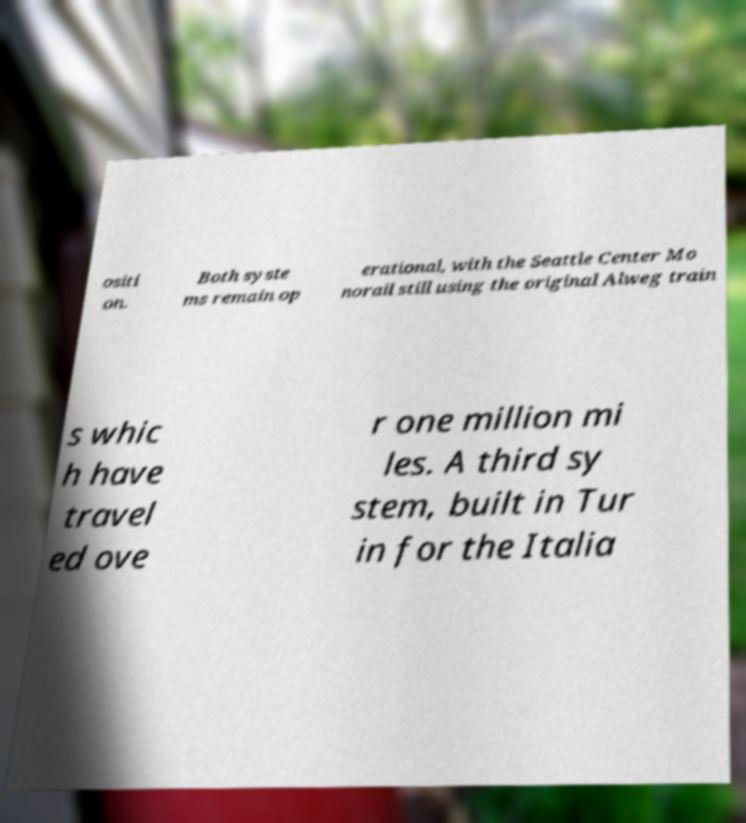Can you accurately transcribe the text from the provided image for me? ositi on. Both syste ms remain op erational, with the Seattle Center Mo norail still using the original Alweg train s whic h have travel ed ove r one million mi les. A third sy stem, built in Tur in for the Italia 